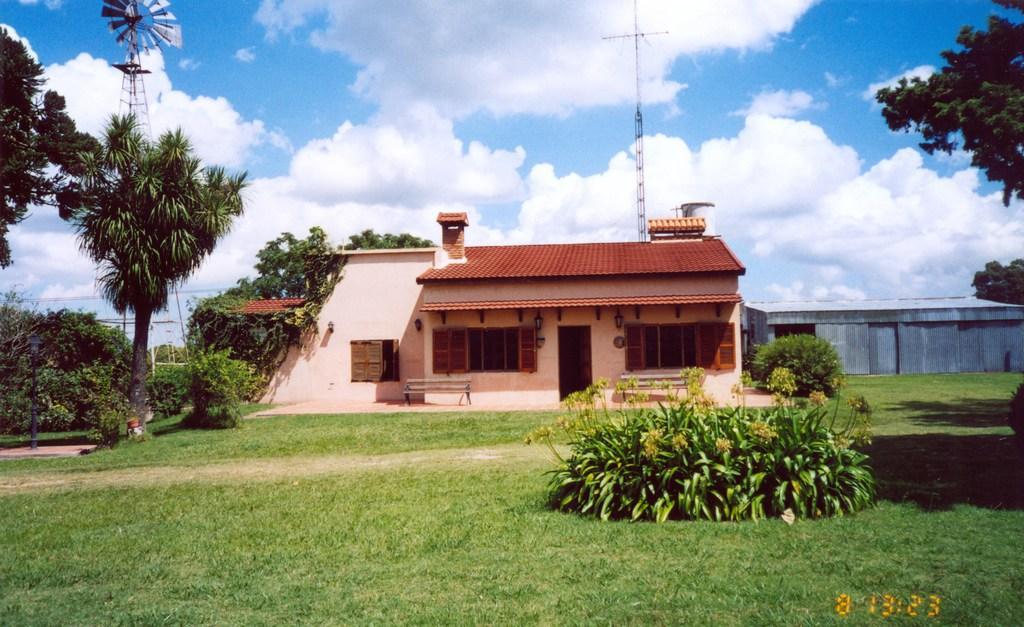How would you summarize this image in a sentence or two? At the bottom of the image there is a ground with grass and bushes with leaves and flowers. In the image there is a house with walls, windows, roofs, doors and also there is a chimney. Beside the house there is a wall. In the background there are many trees and also there is a windmill and a tower. At the top of the image there is a sky with clouds. 